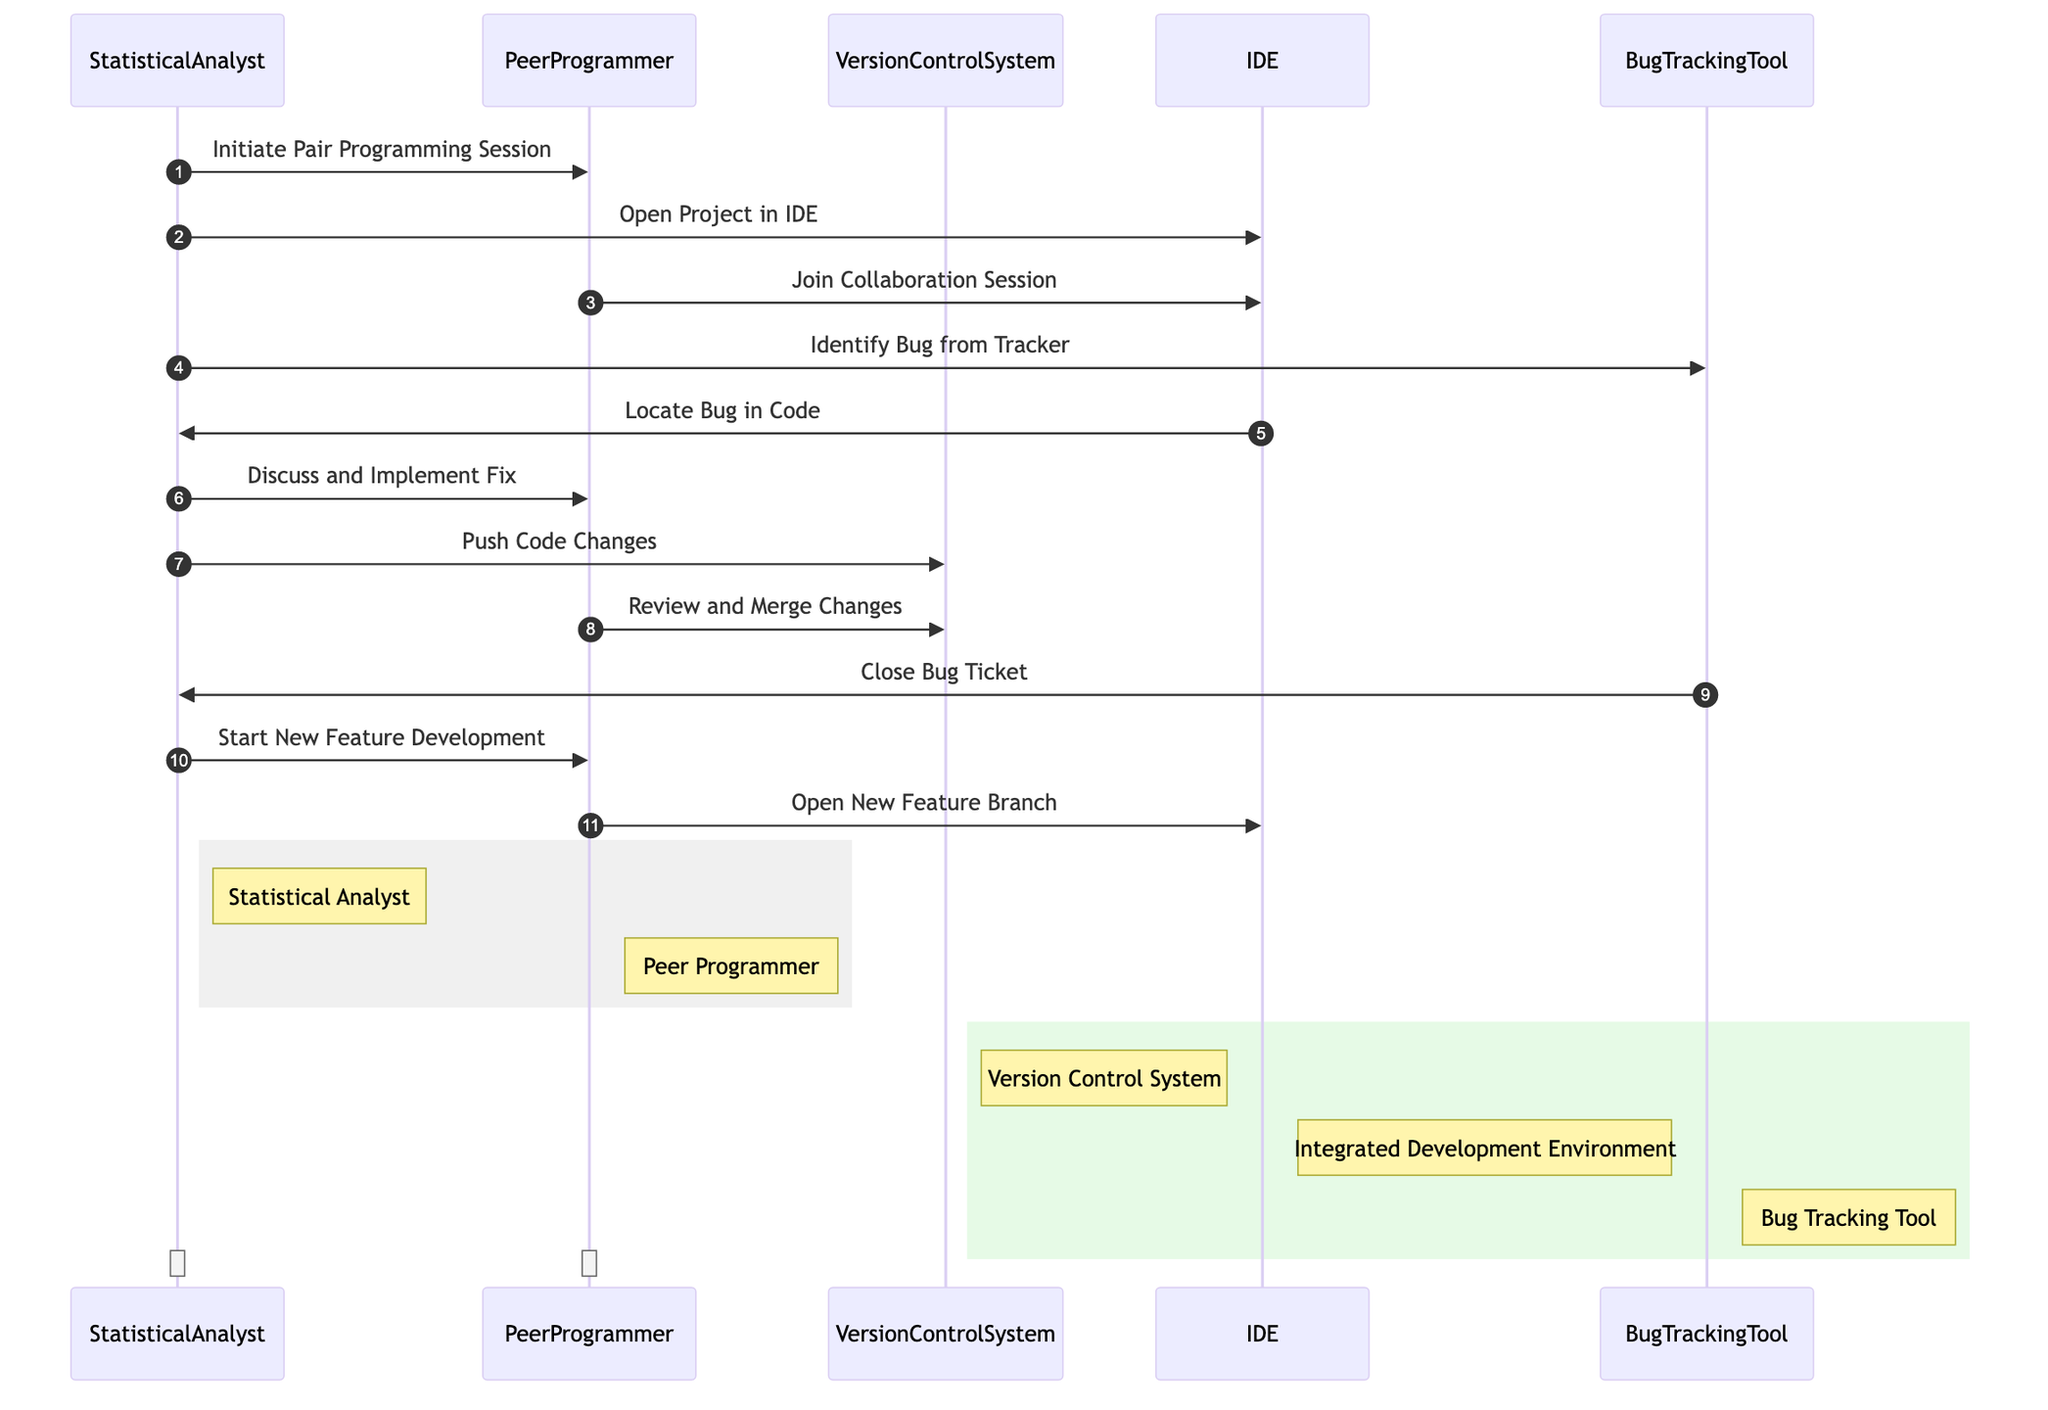What is the first action initiated by the Statistical Analyst? The first action in the sequence diagram shows the Statistical Analyst initiating the Pair Programming Session with the Peer Programmer. This is the very first message exchanged in the interactions.
Answer: Initiate Pair Programming Session How many systems are involved in the sequence diagram? The sequence diagram includes three systems: Version Control System, Integrated Development Environment (IDE), and Bug Tracking Tool. Counting these gives a total of three systems involved.
Answer: 3 Which system is used to identify a bug? The Statistical Analyst interacts with the Bug Tracking Tool to identify a bug. This is shown in the message from the Statistical Analyst to the Bug Tracking Tool.
Answer: Bug Tracking Tool What step follows after discussing and implementing the fix? After discussing and implementing the fix, the next step is for the Statistical Analyst to push code changes to the Version Control System. This can be traced as the next action in the sequence following the discussion.
Answer: Push Code Changes Which participant reviews and merges the changes? The Peer Programmer reviews and merges the changes into the Version Control System. This is indicated by the message that flows from the Peer Programmer to the Version Control System in the diagram.
Answer: Peer Programmer What happens after closing the bug ticket? Following the closing of the bug ticket, the next action initiated by the Statistical Analyst is to start new feature development. This sequence of events can be followed logically in the diagram's flow.
Answer: Start New Feature Development In what order do the participants interact with the IDE? The Statistical Analyst first opens the project in the IDE, followed by the Peer Programmer joining the collaboration session in the IDE. This order is clearly represented in the sequence of messages in the diagram.
Answer: Statistical Analyst, Peer Programmer What type of activity does the rectangle around the Statistical Analyst and Peer Programmer illustrate? The rectangle around the Statistical Analyst and Peer Programmer indicates that they are engaged in collaborative activities during the pair programming session. This concept is visually represented in the diagram by grouping them together.
Answer: Collaborative activities How many interactions are initiated by the Statistical Analyst? The Statistical Analyst initiates five interactions as identified by counting the arrows pointing from the Statistical Analyst to other entities. The messages correspond to the steps they take to navigate the workflow.
Answer: 5 